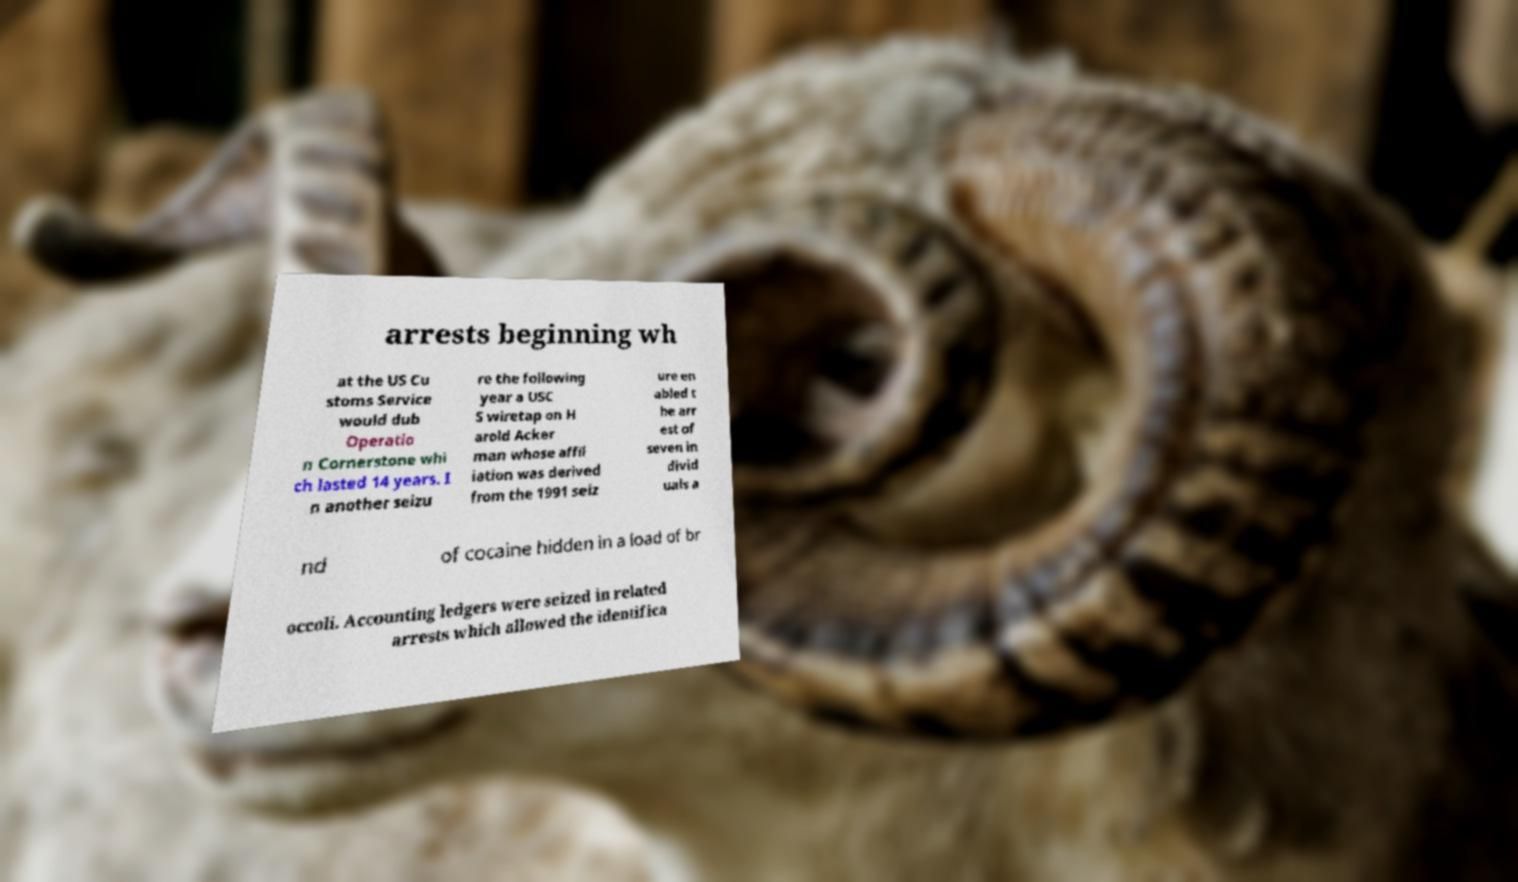Could you assist in decoding the text presented in this image and type it out clearly? arrests beginning wh at the US Cu stoms Service would dub Operatio n Cornerstone whi ch lasted 14 years. I n another seizu re the following year a USC S wiretap on H arold Acker man whose affil iation was derived from the 1991 seiz ure en abled t he arr est of seven in divid uals a nd of cocaine hidden in a load of br occoli. Accounting ledgers were seized in related arrests which allowed the identifica 